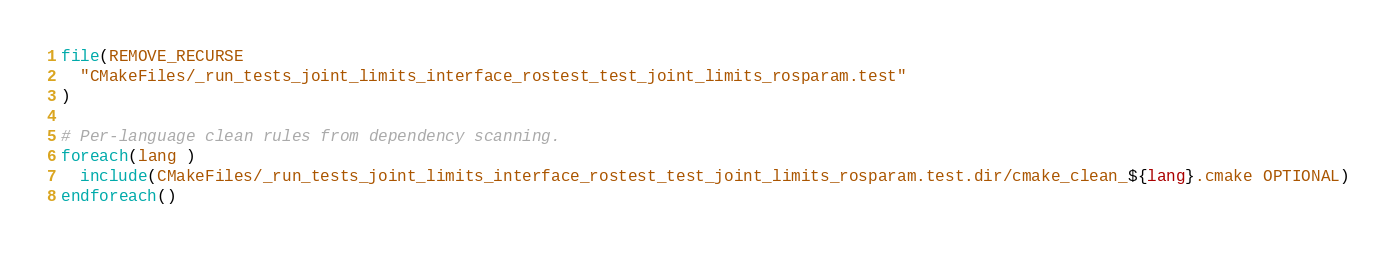<code> <loc_0><loc_0><loc_500><loc_500><_CMake_>file(REMOVE_RECURSE
  "CMakeFiles/_run_tests_joint_limits_interface_rostest_test_joint_limits_rosparam.test"
)

# Per-language clean rules from dependency scanning.
foreach(lang )
  include(CMakeFiles/_run_tests_joint_limits_interface_rostest_test_joint_limits_rosparam.test.dir/cmake_clean_${lang}.cmake OPTIONAL)
endforeach()
</code> 